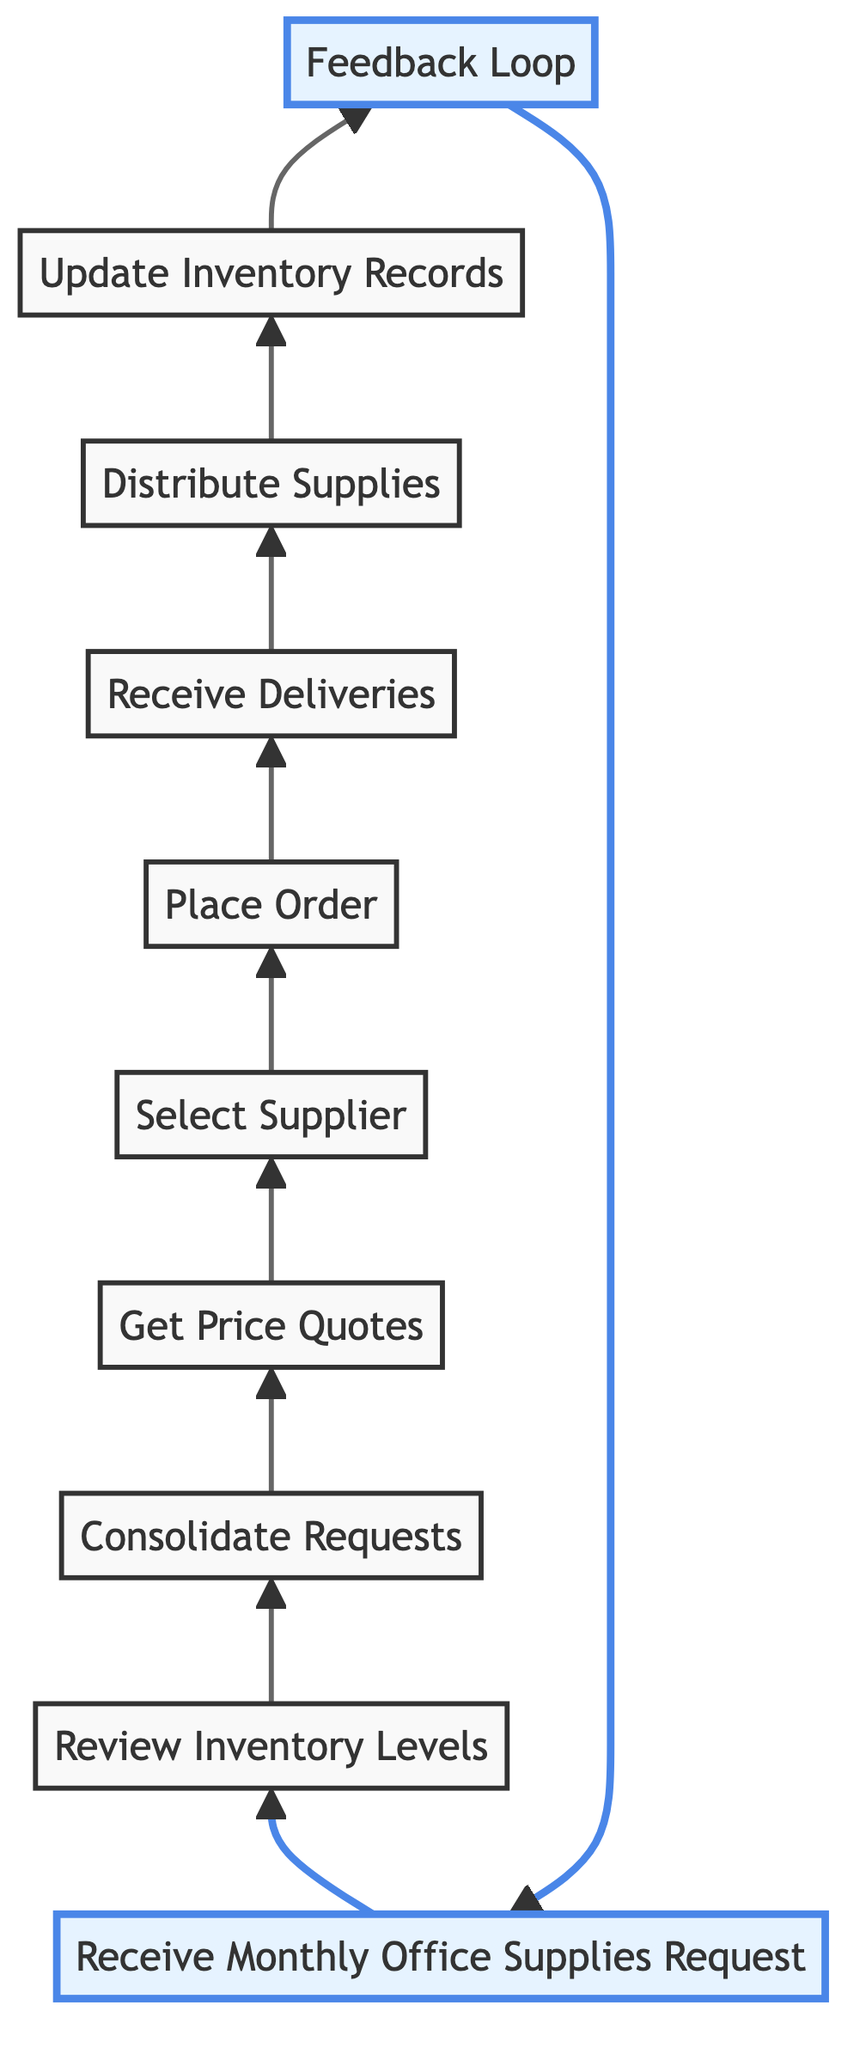What is the first step in the process? The first step in the process is identified in the diagram as "Receive Monthly Office Supplies Request," which is the starting point of the flow.
Answer: Receive Monthly Office Supplies Request How many total steps are shown in the diagram? Counting all the unique nodes in the flowchart, there are ten distinct steps in the procurement process.
Answer: Ten Which steps are highlighted in the diagram? The highlighted steps in the diagram are "Receive Monthly Office Supplies Request" and "Feedback Loop," indicating their significance in the process.
Answer: Receive Monthly Office Supplies Request, Feedback Loop What comes immediately after reviewing inventory levels? After "Review Inventory Levels," the next step is "Consolidate Requests," demonstrating the flow from inventory assessment to request consolidation.
Answer: Consolidate Requests What is the last action taken in the procurement process? The last action is "Feedback Loop," where feedback is gathered regarding the supplied materials, completing the cycle of procurement.
Answer: Feedback Loop Which step follows placing the order? Following the "Place Order" node, the next step in the flow is "Receive Deliveries," indicating the transition from ordering to receiving.
Answer: Receive Deliveries How does the "Update Inventory Records" node connect to the overall flow? "Update Inventory Records" comes after "Distribute Supplies," ensuring that records are accurate post-distribution, thus linking to supply management.
Answer: After Distribute Supplies Which step involves evaluating supplier options? The step that involves evaluating supplier options is "Select Supplier," where the best quotation is chosen based on received quotes.
Answer: Select Supplier What is the purpose of the "Feedback Loop" step? The "Feedback Loop" step is intended to gather insights from departments regarding the received supplies, ensuring continuous improvement.
Answer: Gather feedback How many connections stem from the "Get Price Quotes" node? From "Get Price Quotes," there is one direct connection leading to "Select Supplier," showing the progression in the procurement process.
Answer: One 